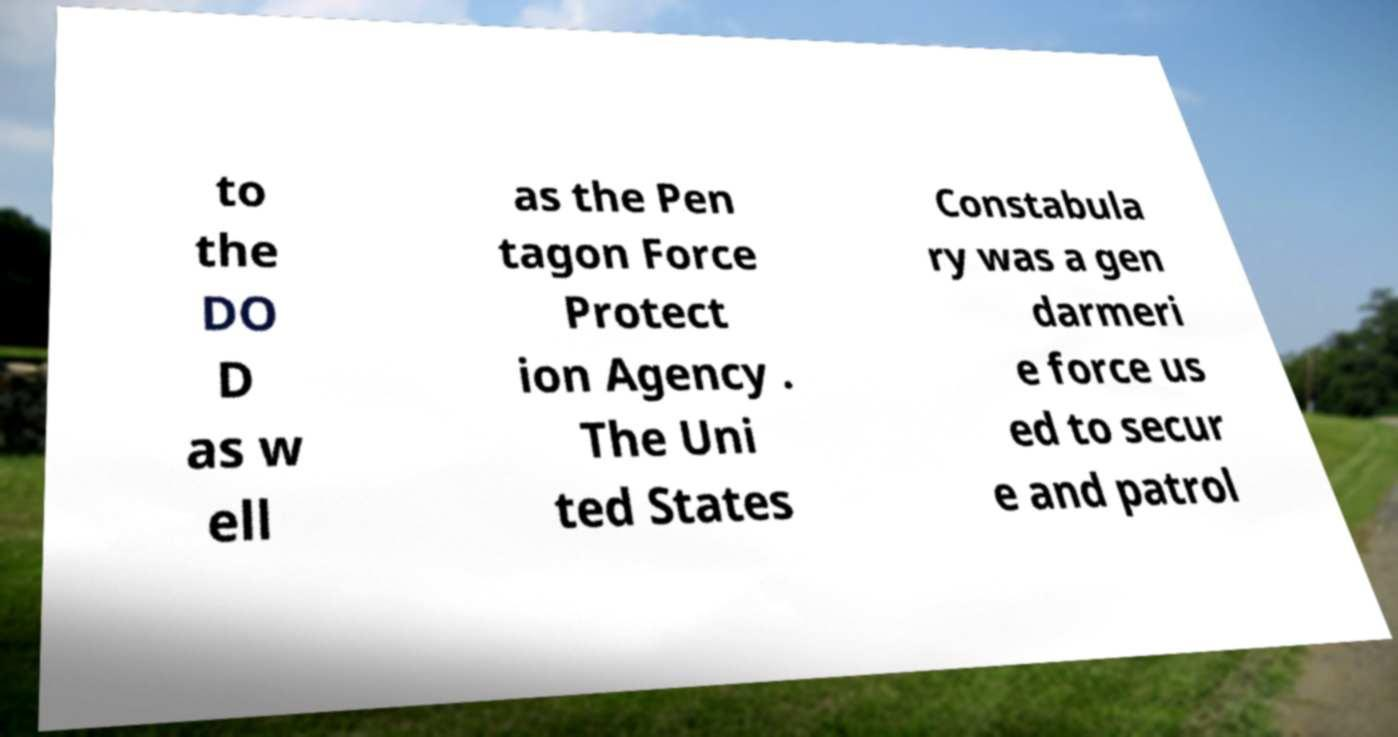There's text embedded in this image that I need extracted. Can you transcribe it verbatim? to the DO D as w ell as the Pen tagon Force Protect ion Agency . The Uni ted States Constabula ry was a gen darmeri e force us ed to secur e and patrol 